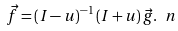<formula> <loc_0><loc_0><loc_500><loc_500>\vec { f } = ( I - u ) ^ { - 1 } \, ( I + u ) \, \vec { g } . \ n</formula> 